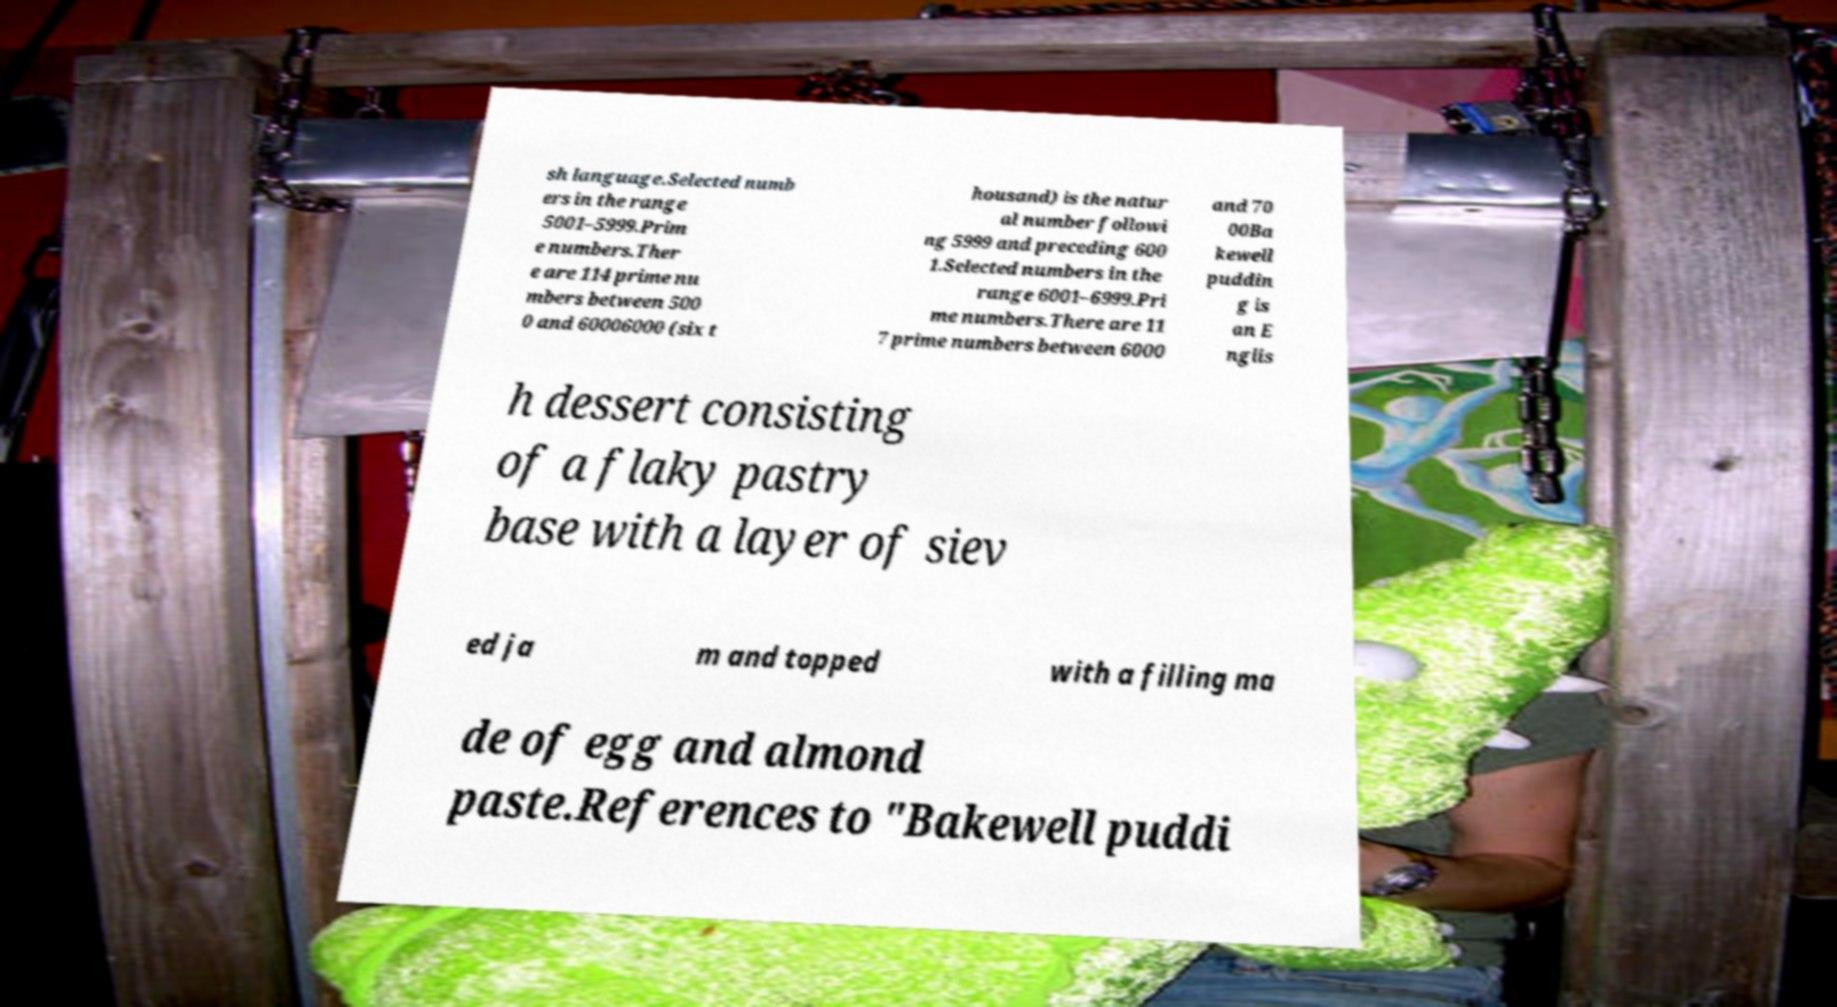Could you assist in decoding the text presented in this image and type it out clearly? sh language.Selected numb ers in the range 5001–5999.Prim e numbers.Ther e are 114 prime nu mbers between 500 0 and 60006000 (six t housand) is the natur al number followi ng 5999 and preceding 600 1.Selected numbers in the range 6001–6999.Pri me numbers.There are 11 7 prime numbers between 6000 and 70 00Ba kewell puddin g is an E nglis h dessert consisting of a flaky pastry base with a layer of siev ed ja m and topped with a filling ma de of egg and almond paste.References to "Bakewell puddi 